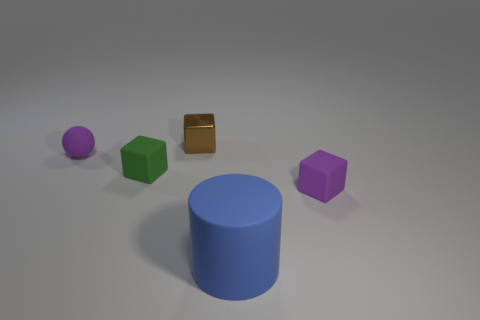Subtract all brown cylinders. Subtract all brown spheres. How many cylinders are left? 1 Add 1 tiny blue metal cubes. How many objects exist? 6 Subtract all blocks. How many objects are left? 2 Subtract all small green rubber cubes. Subtract all tiny purple rubber objects. How many objects are left? 2 Add 1 blue matte cylinders. How many blue matte cylinders are left? 2 Add 5 balls. How many balls exist? 6 Subtract 0 gray cubes. How many objects are left? 5 